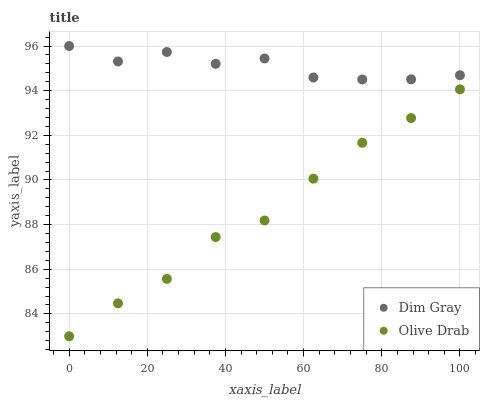Does Olive Drab have the minimum area under the curve?
Answer yes or no. Yes. Does Dim Gray have the maximum area under the curve?
Answer yes or no. Yes. Does Olive Drab have the maximum area under the curve?
Answer yes or no. No. Is Olive Drab the smoothest?
Answer yes or no. Yes. Is Dim Gray the roughest?
Answer yes or no. Yes. Is Olive Drab the roughest?
Answer yes or no. No. Does Olive Drab have the lowest value?
Answer yes or no. Yes. Does Dim Gray have the highest value?
Answer yes or no. Yes. Does Olive Drab have the highest value?
Answer yes or no. No. Is Olive Drab less than Dim Gray?
Answer yes or no. Yes. Is Dim Gray greater than Olive Drab?
Answer yes or no. Yes. Does Olive Drab intersect Dim Gray?
Answer yes or no. No. 